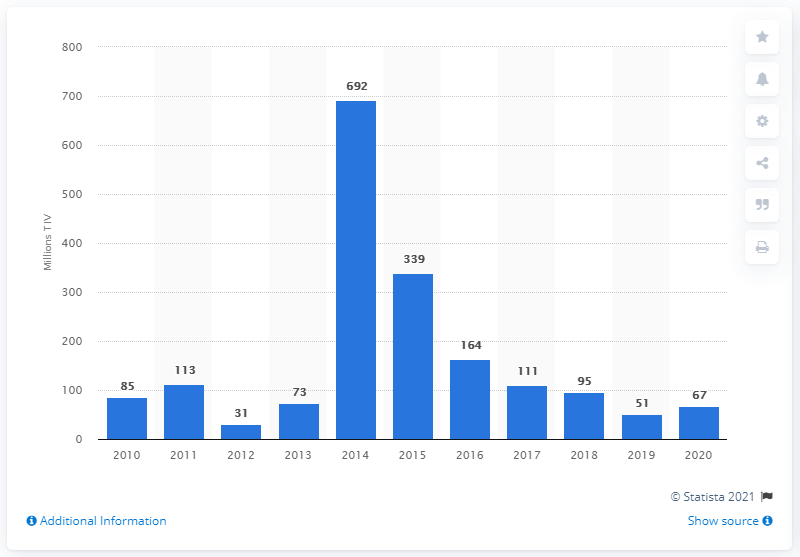Point out several critical features in this image. In 2020, Kuwait's arms import value was $67 million. In 2015, Kuwait's arms imports totaled approximately $339 million. 